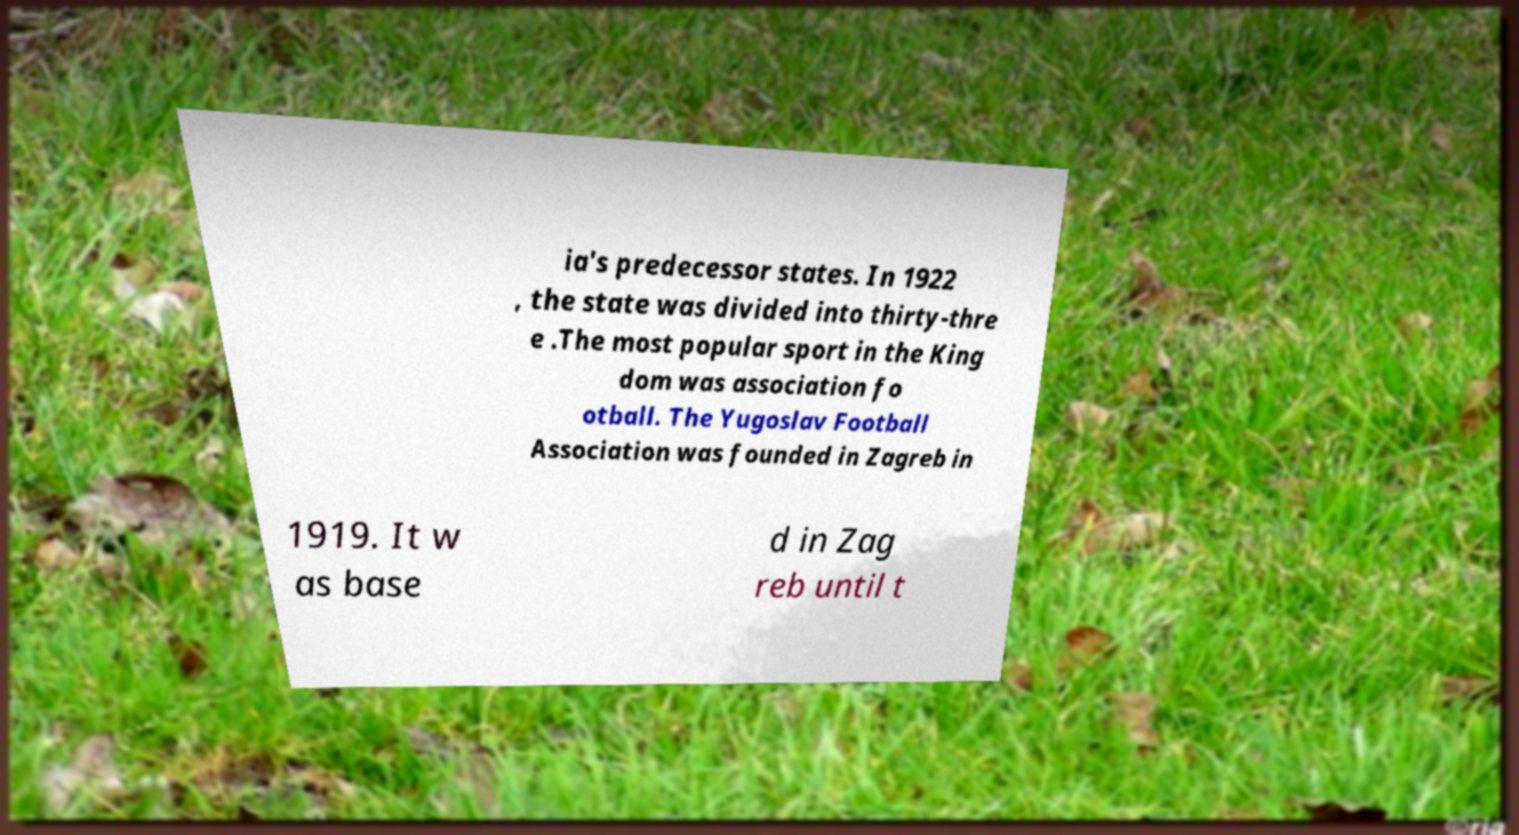What messages or text are displayed in this image? I need them in a readable, typed format. ia's predecessor states. In 1922 , the state was divided into thirty-thre e .The most popular sport in the King dom was association fo otball. The Yugoslav Football Association was founded in Zagreb in 1919. It w as base d in Zag reb until t 